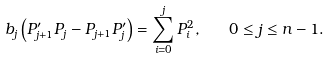<formula> <loc_0><loc_0><loc_500><loc_500>b _ { j } \left ( P ^ { \prime } _ { j + 1 } P _ { j } - P _ { j + 1 } P ^ { \prime } _ { j } \right ) = \sum ^ { j } _ { i = 0 } P _ { i } ^ { 2 } , \quad 0 \leq j \leq n - 1 .</formula> 